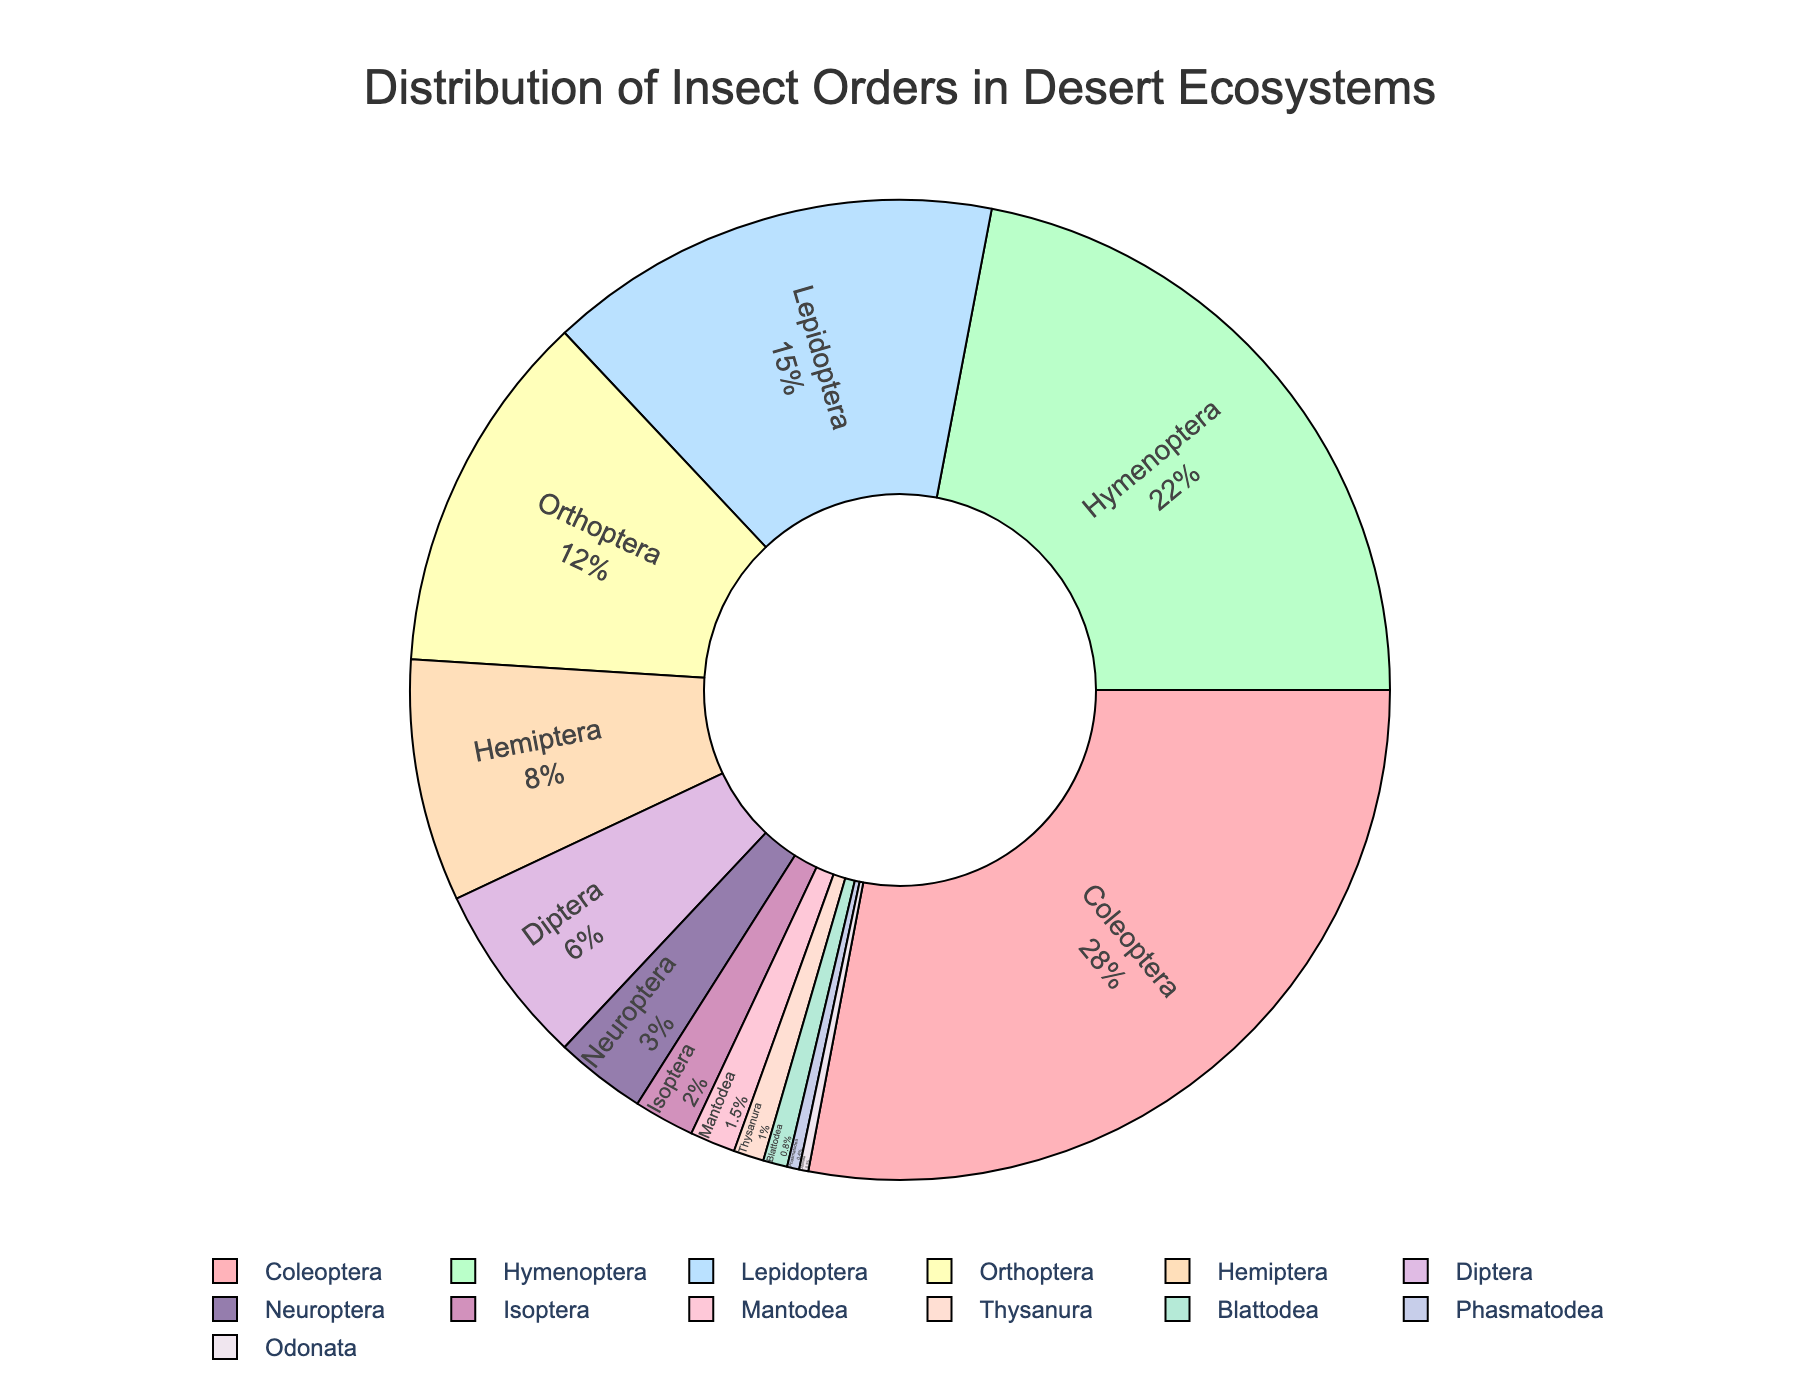What percentage of insect orders are Coleoptera and Hymenoptera combined? To find the combined percentage, add the percentages of Coleoptera and Hymenoptera: 28% + 22% = 50%
Answer: 50% Which insect order has the smallest percentage in the desert ecosystems? To find the smallest percentage, look for the order with the lowest value. Phasmatodea has 0.4%, which is the smallest
Answer: Phasmatodea By how much is the percentage of Coleoptera greater than Lepidoptera? To find the difference, subtract the percentage of Lepidoptera from Coleoptera: 28% - 15% = 13%
Answer: 13% Which two insect orders combined make up exactly 10% of the distribution? To find two orders that combine to 10%, check combinations of percentages. Hemiptera (8%) and Mantodea (1.5%) combined make 9.5%, but Diptera (6%) and Isoptera (2%) combine to 8%. No two orders make exactly 10%
Answer: None Which insect order is represented by the third-largest percentage? To find the third-largest percentage, identify the three largest. After Coleoptera (28%) and Hymenoptera (22%), Lepidoptera is next with 15%
Answer: Lepidoptera What is the total percentage of insect orders that make up less than 3% each? Sum the percentages of orders less than 3%: Neuroptera (3%), Isoptera (2%), Mantodea (1.5%), Thysanura (1%), Blattodea (0.8%), Phasmatodea (0.4%), Odonata (0.3%). Total = 9.0%
Answer: 9.0% Is the combined percentage of Hymenoptera and Diptera greater or less than Coleoptera? Sum of Hymenoptera and Diptera is 22% + 6% = 28%, which is equal to the percentage of Coleoptera
Answer: Equal Which insect orders are represented by colors the most distinct from each other? For visual distinctiveness, typically contrasting colors like red and green or blue and yellow are checked. Without the actual colors, we assume extreme positions in the color palette can be distinct. Coleoptera (RGB #FFB3BA) and Neuroptera (RGB #F0E6EF) are far apart in the palette
Answer: Coleoptera and Neuroptera How many insect orders comprise less than 5% of the distribution? Count the orders with less than 5%: Neuroptera (3%), Isoptera (2%), Mantodea (1.5%), Thysanura (1%), Blattodea (0.8%), Phasmatodea (0.4%), Odonata (0.3%). There are 7 such orders
Answer: 7 